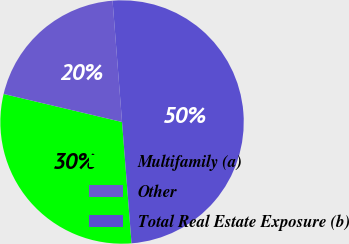Convert chart to OTSL. <chart><loc_0><loc_0><loc_500><loc_500><pie_chart><fcel>Multifamily (a)<fcel>Other<fcel>Total Real Estate Exposure (b)<nl><fcel>29.94%<fcel>20.06%<fcel>50.0%<nl></chart> 